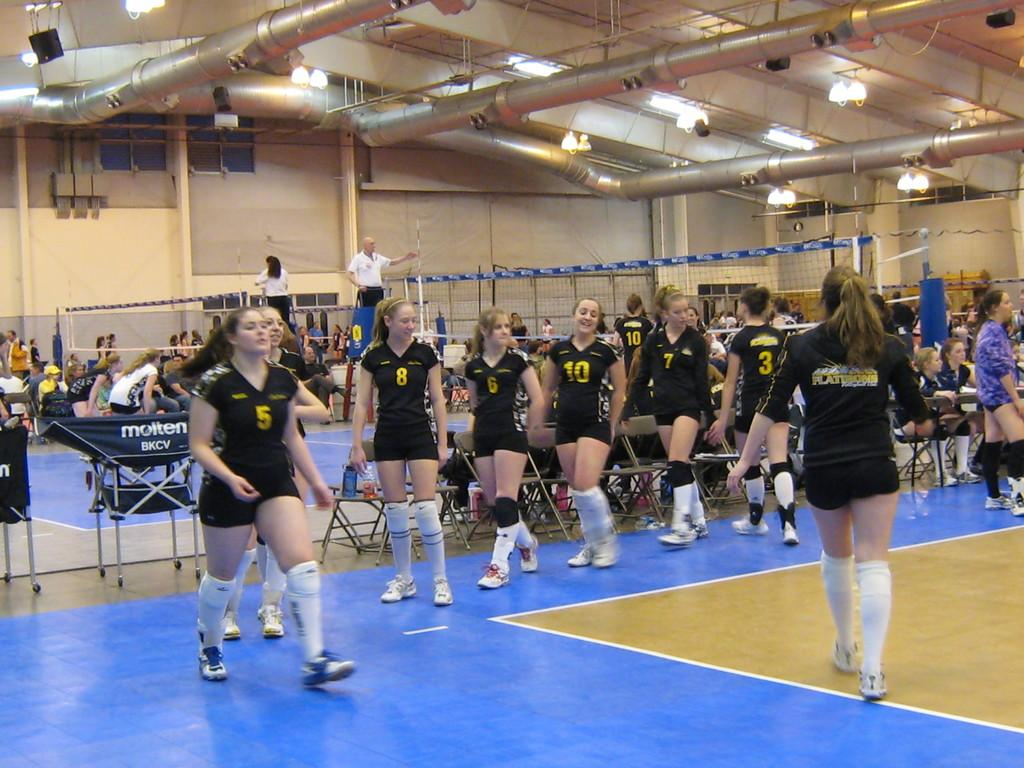<image>
Provide a brief description of the given image. Players number 5, 8, 6, 10, 7 and 3 for a volleyball team. 